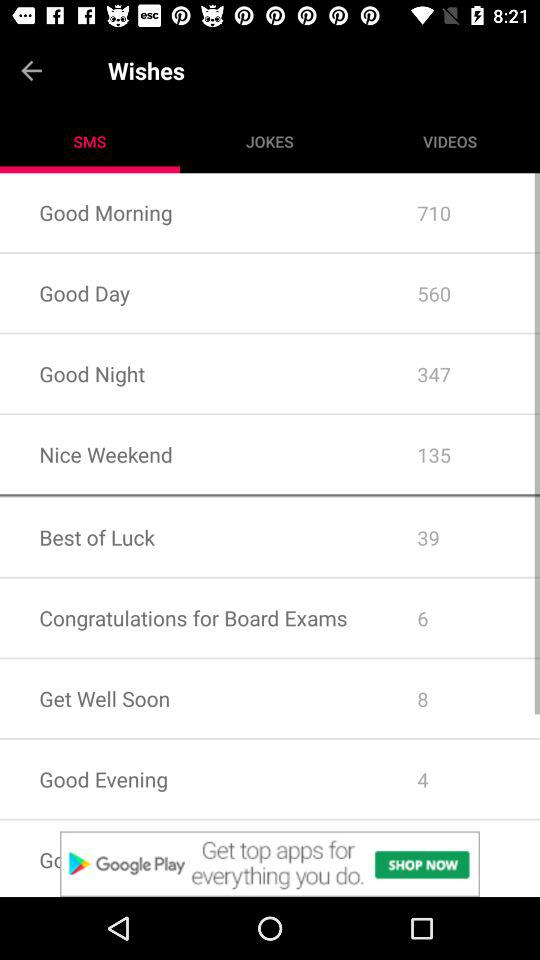How many messages are there in "Good Day"? There are 560 messages in "Good Day". 